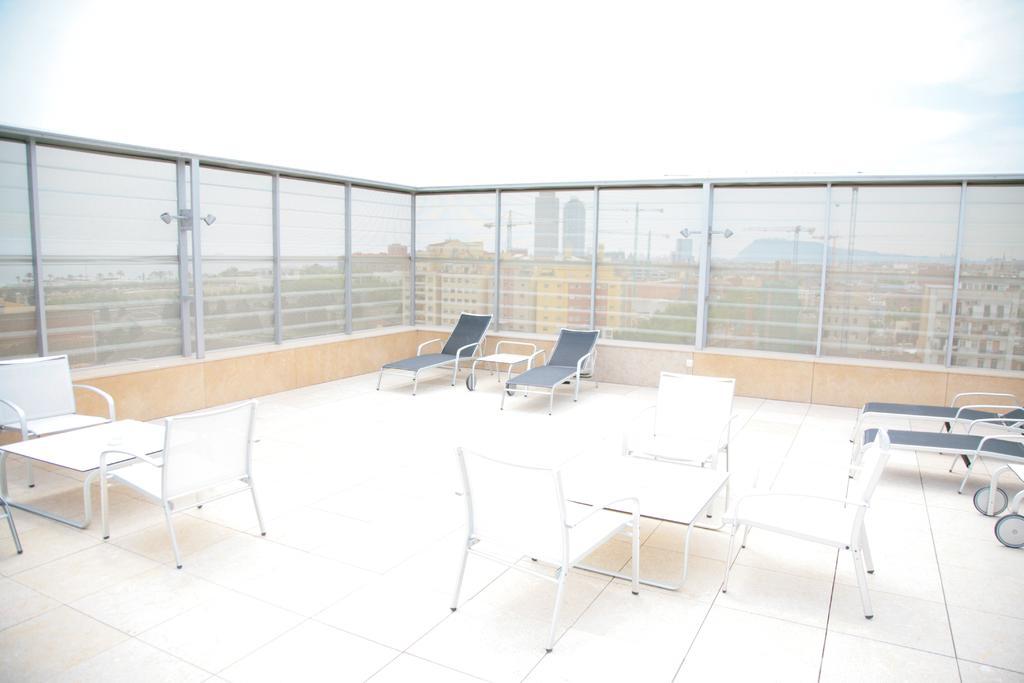Describe this image in one or two sentences. This image is taken on balcony of a building with chairs and tables on the floor with a glass fence behind it and over the background there are many buildings and above its sky with clouds. 